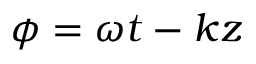Convert formula to latex. <formula><loc_0><loc_0><loc_500><loc_500>\phi = \omega t - k z</formula> 